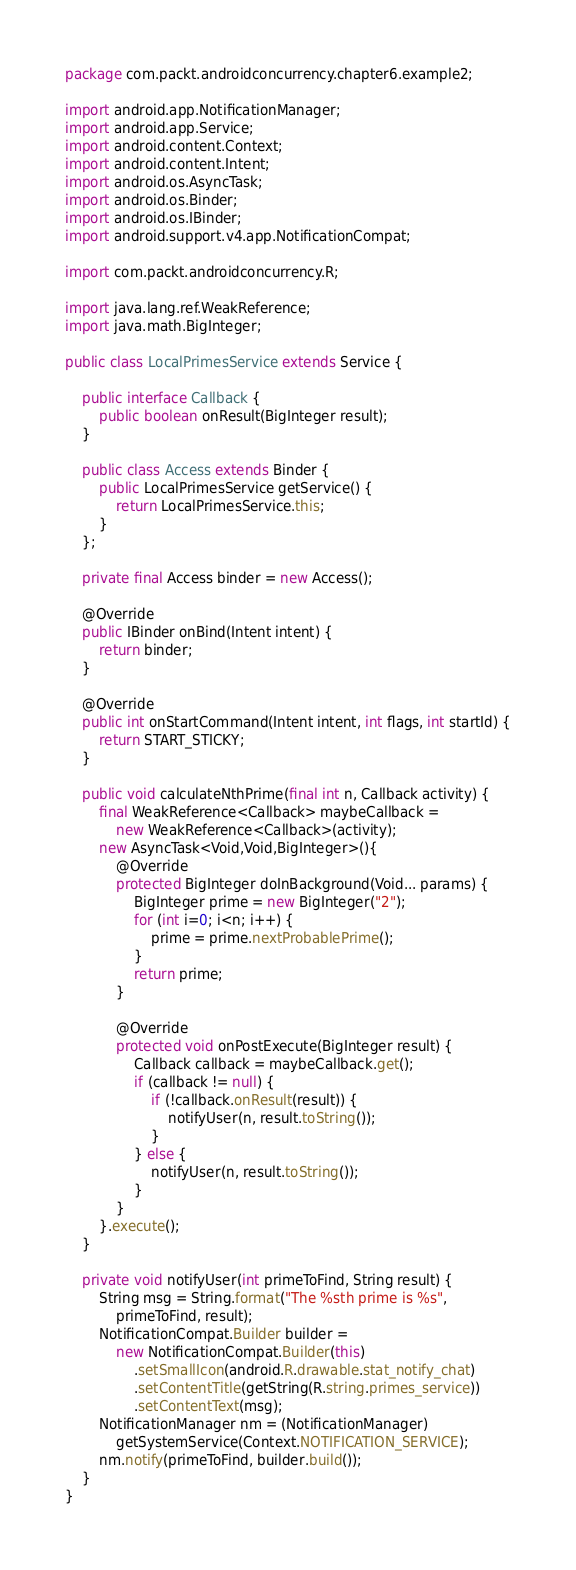<code> <loc_0><loc_0><loc_500><loc_500><_Java_>package com.packt.androidconcurrency.chapter6.example2;

import android.app.NotificationManager;
import android.app.Service;
import android.content.Context;
import android.content.Intent;
import android.os.AsyncTask;
import android.os.Binder;
import android.os.IBinder;
import android.support.v4.app.NotificationCompat;

import com.packt.androidconcurrency.R;

import java.lang.ref.WeakReference;
import java.math.BigInteger;

public class LocalPrimesService extends Service {

    public interface Callback {
        public boolean onResult(BigInteger result);
    }

    public class Access extends Binder {
        public LocalPrimesService getService() {
            return LocalPrimesService.this;
        }
    };

    private final Access binder = new Access();

    @Override
    public IBinder onBind(Intent intent) {
        return binder;
    }

    @Override
    public int onStartCommand(Intent intent, int flags, int startId) {
        return START_STICKY;
    }

    public void calculateNthPrime(final int n, Callback activity) {
        final WeakReference<Callback> maybeCallback =
            new WeakReference<Callback>(activity);
        new AsyncTask<Void,Void,BigInteger>(){
            @Override
            protected BigInteger doInBackground(Void... params) {
                BigInteger prime = new BigInteger("2");
                for (int i=0; i<n; i++) {
                    prime = prime.nextProbablePrime();
                }
                return prime;
            }

            @Override
            protected void onPostExecute(BigInteger result) {
                Callback callback = maybeCallback.get();
                if (callback != null) {
                    if (!callback.onResult(result)) {
                        notifyUser(n, result.toString());
                    }
                } else {
                    notifyUser(n, result.toString());
                }
            }
        }.execute();
    }

    private void notifyUser(int primeToFind, String result) {
        String msg = String.format("The %sth prime is %s",
            primeToFind, result);
        NotificationCompat.Builder builder =
            new NotificationCompat.Builder(this)
                .setSmallIcon(android.R.drawable.stat_notify_chat)
                .setContentTitle(getString(R.string.primes_service))
                .setContentText(msg);
        NotificationManager nm = (NotificationManager)
            getSystemService(Context.NOTIFICATION_SERVICE);
        nm.notify(primeToFind, builder.build());
    }
}
</code> 